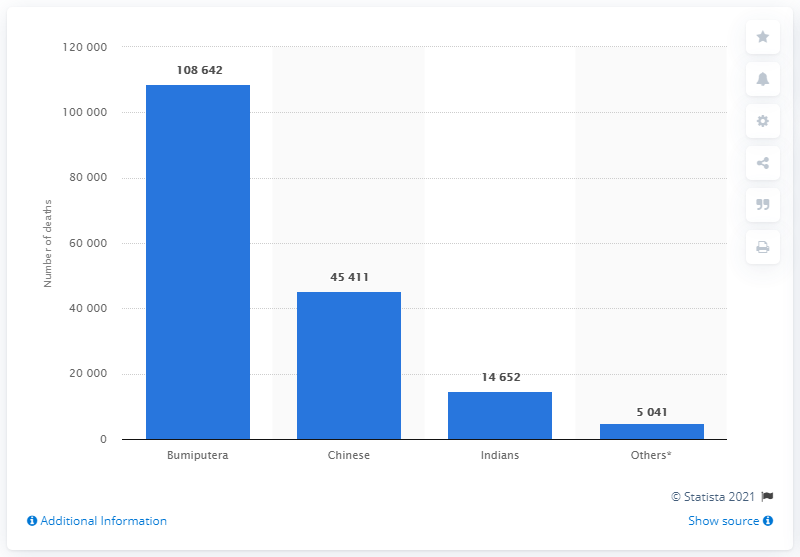Identify some key points in this picture. The death rate among the Bumiputera population in Malaysia in 2019 was 108,642. In 2019, there were 45,411 reported deaths among the Chinese population. 